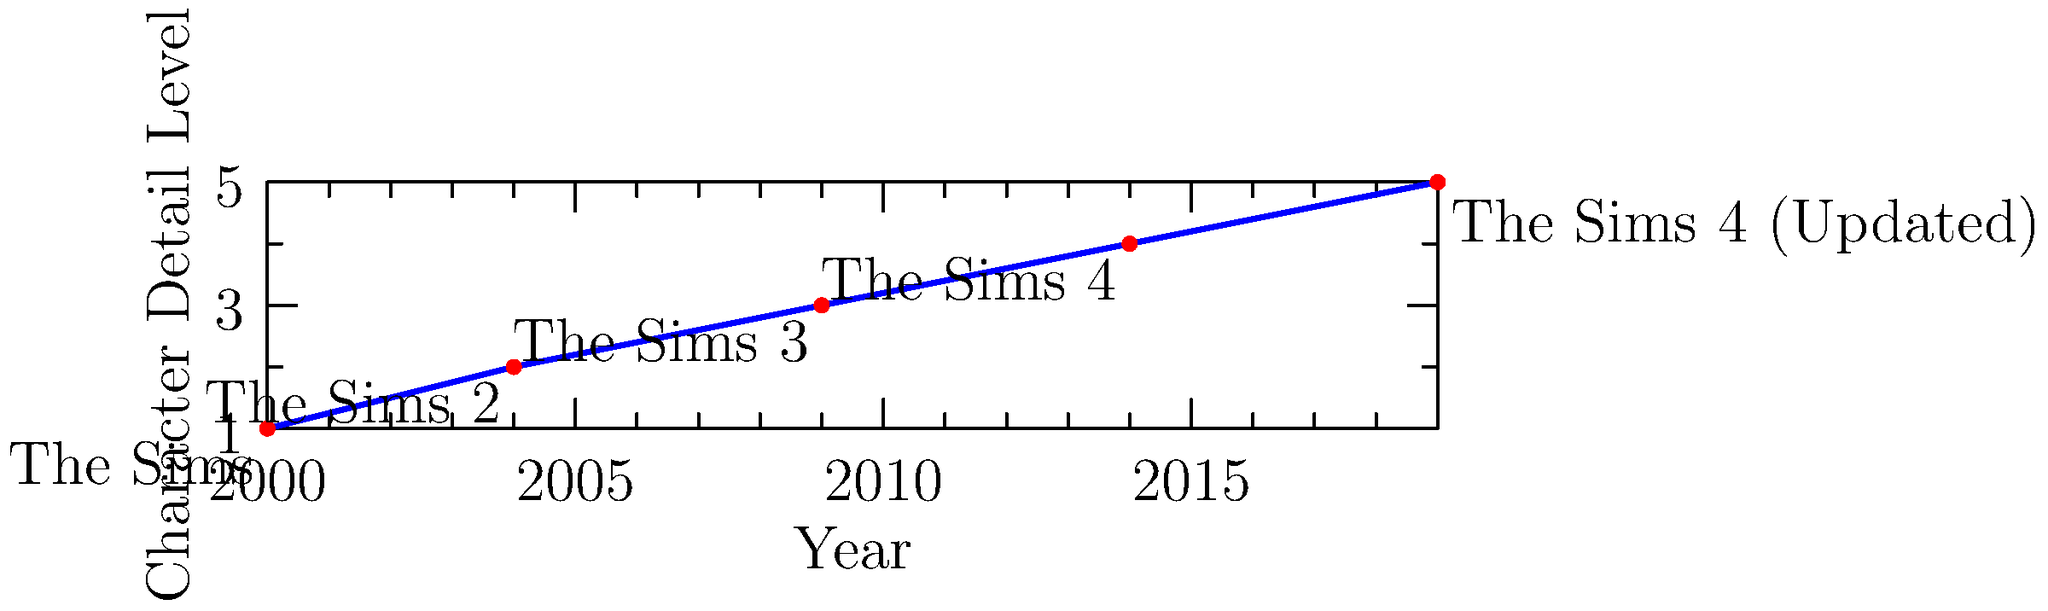Analyze the evolution of Sim character design across The Sims series as depicted in the timeline. Which game version marked the most significant leap in character detail and realism, and how did this impact the overall gameplay experience for long-term fans? To answer this question, let's examine the timeline step-by-step:

1. The Sims (2000): This was the original game with basic character models.

2. The Sims 2 (2004): There was a noticeable improvement in character detail, moving from 2D to 3D models.

3. The Sims 3 (2009): Another increase in character detail, introducing more realistic features and expressions.

4. The Sims 4 (2014): Surprisingly, this version shows a slight regression in the level of detail compared to The Sims 3.

5. The Sims 4 (Updated, 2019): A significant jump in character detail, surpassing all previous versions.

The most significant leap in character detail and realism occurred between The Sims (2000) and The Sims 2 (2004). This transition marked the shift from 2D to 3D character models, fundamentally changing the gameplay experience.

For long-term fans, this leap had a profound impact:
1. Enhanced immersion: 3D models allowed for more realistic interactions and expressions.
2. Improved customization: Players could create more detailed and unique Sims.
3. New gameplay mechanics: 3D environments enabled features like aging and genetics.
4. Emotional connection: More detailed characters fostered stronger player-Sim relationships.

While later versions continued to improve, none matched the revolutionary change from 2D to 3D in terms of impact on the core gameplay experience.
Answer: The Sims 2 (2004), transitioning from 2D to 3D models. 